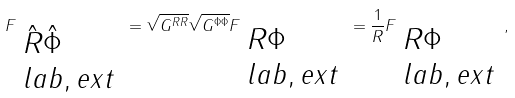<formula> <loc_0><loc_0><loc_500><loc_500>F _ { \begin{array} { l } \hat { R } \hat { \Phi } \\ l a b , e x t \\ \end{array} } = \sqrt { G ^ { R R } } \sqrt { G ^ { \Phi \Phi } } F _ { \begin{array} { l } R \Phi \\ l a b , e x t \\ \end{array} } = \frac { 1 } { R } F _ { \begin{array} { l } R \Phi \\ l a b , e x t \\ \end{array} } ,</formula> 